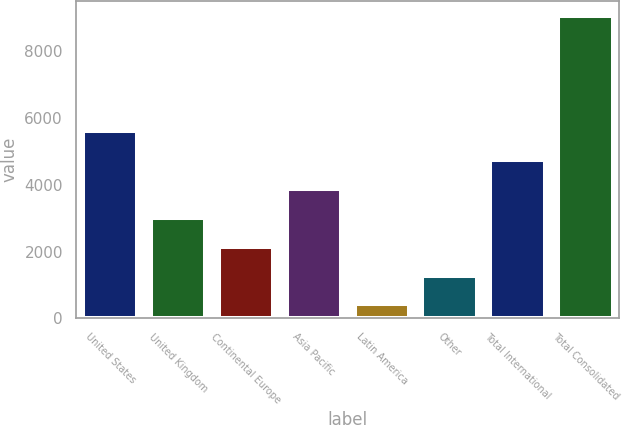Convert chart to OTSL. <chart><loc_0><loc_0><loc_500><loc_500><bar_chart><fcel>United States<fcel>United Kingdom<fcel>Continental Europe<fcel>Asia Pacific<fcel>Latin America<fcel>Other<fcel>Total International<fcel>Total Consolidated<nl><fcel>5600.6<fcel>3008.9<fcel>2145<fcel>3872.8<fcel>417.2<fcel>1281.1<fcel>4736.7<fcel>9056.2<nl></chart> 